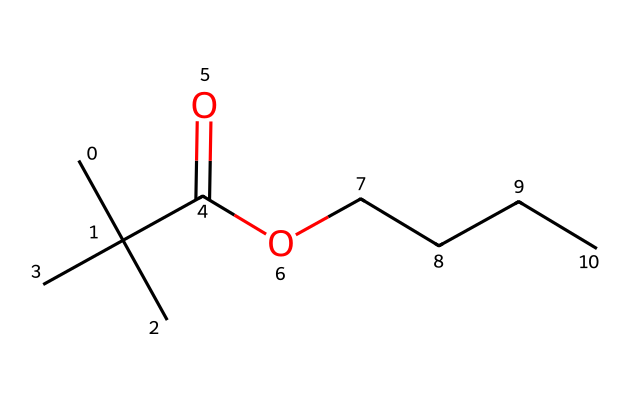What is the total number of carbon atoms in the structure? To count the carbon atoms in the SMILES representation, we can identify each 'C' in the structure. The given SMILES shows 'CC(C)(C)' indicating there are four carbon atoms in the branched chain, plus 'CCCC' representing four more linear carbons. Thus, the total number of carbon atoms is 4 + 4 = 8.
Answer: 8 How many oxygen atoms are present in this compound? The SMILES contains 'C(=O)O', where the '=O' indicates a double-bonded oxygen (carbonyl), and the 'O' indicates another single-bonded oxygen (hydroxyl). This means there are two oxygen atoms in total in the structure.
Answer: 2 What type of functional group is present in the chemical structure? The presence of 'C(=O)O' in the SMILES indicates that there is a carboxylic acid functional group. This functional group is characterized by the carbonyl (C=O) and hydroxyl (–OH) groups bonded to the same carbon atom.
Answer: carboxylic acid Is this compound a saturated or unsaturated compound? The presence of single bonds only in the branched and linear alkyl portions indicates that all additional carbon connections are saturated with hydrogen. There is no double or triple bond in the carbon chain apart from the functional group, so it is considered a saturated compound.
Answer: saturated How does the branching in the carbon chain affect the compound's properties? The branching in the carbon chain typically increases the compound's solubility in organic solvents and may influence its viscosity and saturation. Branching tends to lower the boiling point compared to straight-chain counterparts, affecting the paint performance in application.
Answer: affects solubility and viscosity What is the primary use of this type of compound in acrylic paints? Such compounds with carboxylic acid groups are utilized to enhance the binding properties and adhesion of the pigments in acrylic paints, thus contributing to improved durability and finish of the paint.
Answer: binding properties 